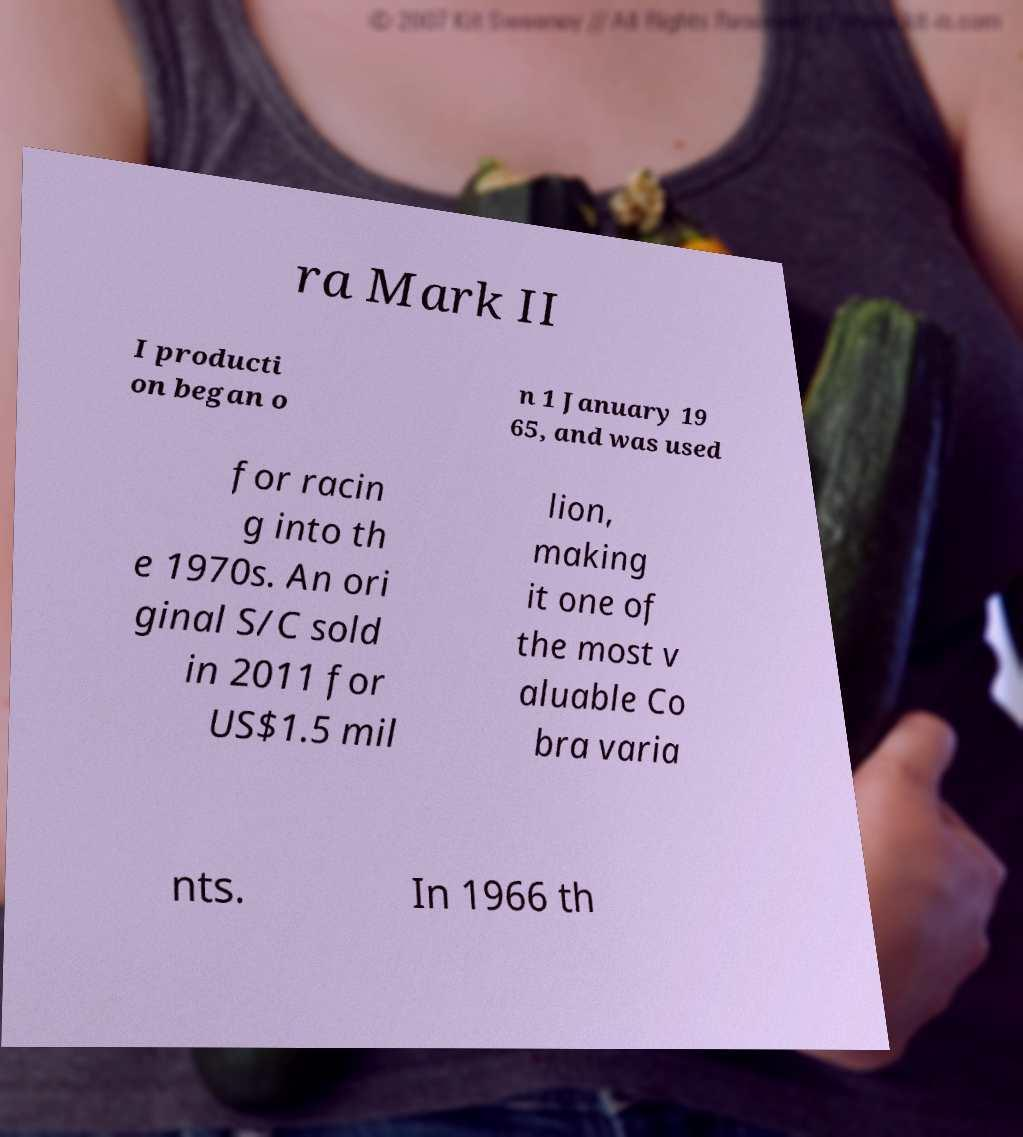What messages or text are displayed in this image? I need them in a readable, typed format. ra Mark II I producti on began o n 1 January 19 65, and was used for racin g into th e 1970s. An ori ginal S/C sold in 2011 for US$1.5 mil lion, making it one of the most v aluable Co bra varia nts. In 1966 th 